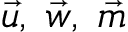Convert formula to latex. <formula><loc_0><loc_0><loc_500><loc_500>\vec { u } , \, \vec { w } , \, \vec { m }</formula> 